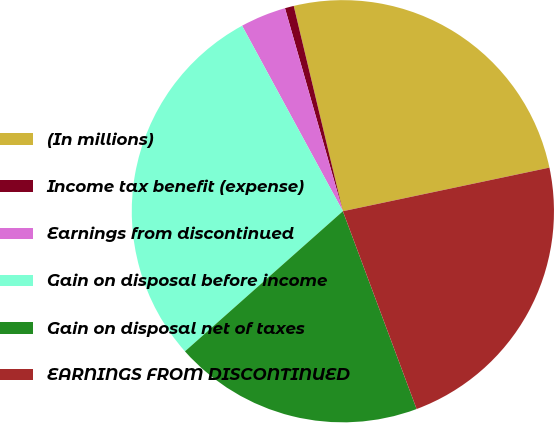Convert chart to OTSL. <chart><loc_0><loc_0><loc_500><loc_500><pie_chart><fcel>(In millions)<fcel>Income tax benefit (expense)<fcel>Earnings from discontinued<fcel>Gain on disposal before income<fcel>Gain on disposal net of taxes<fcel>EARNINGS FROM DISCONTINUED<nl><fcel>25.43%<fcel>0.68%<fcel>3.5%<fcel>28.63%<fcel>19.13%<fcel>22.63%<nl></chart> 